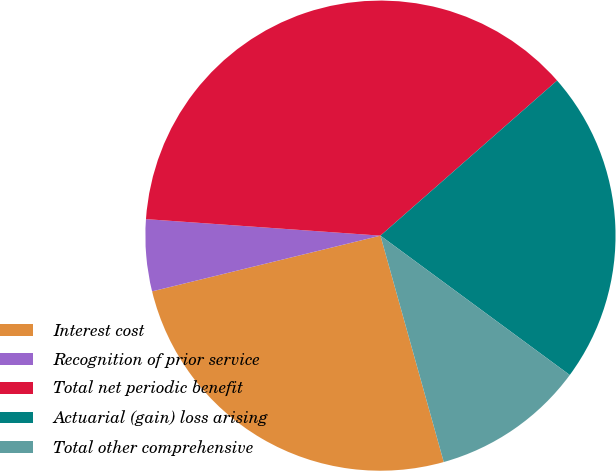<chart> <loc_0><loc_0><loc_500><loc_500><pie_chart><fcel>Interest cost<fcel>Recognition of prior service<fcel>Total net periodic benefit<fcel>Actuarial (gain) loss arising<fcel>Total other comprehensive<nl><fcel>25.53%<fcel>4.93%<fcel>37.41%<fcel>21.57%<fcel>10.56%<nl></chart> 